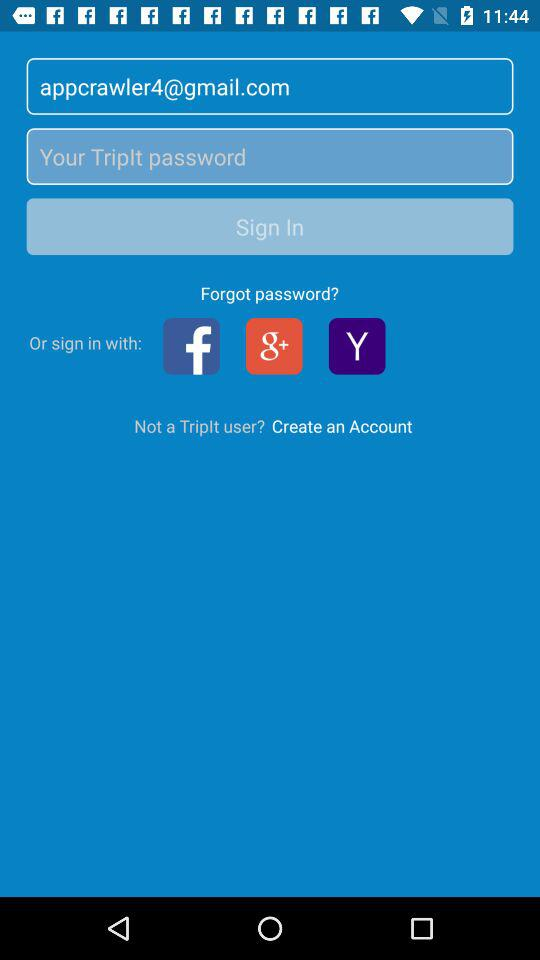How many characters are required for the password?
When the provided information is insufficient, respond with <no answer>. <no answer> 